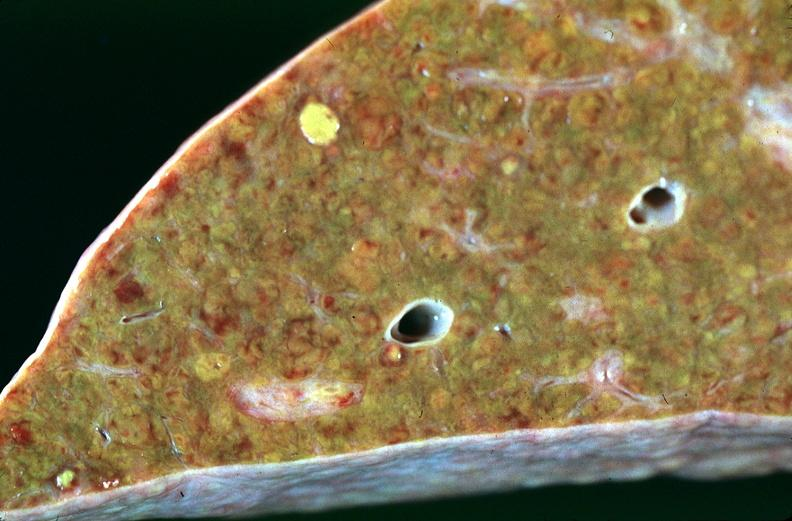what is present?
Answer the question using a single word or phrase. Hepatobiliary 